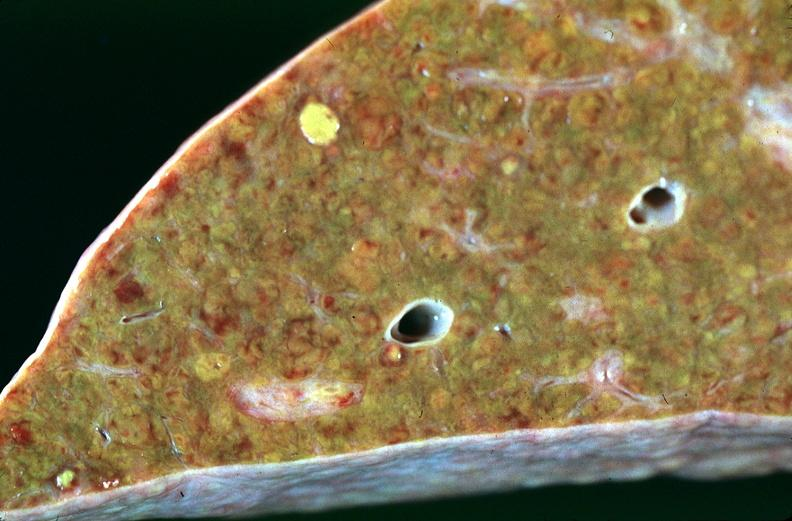what is present?
Answer the question using a single word or phrase. Hepatobiliary 